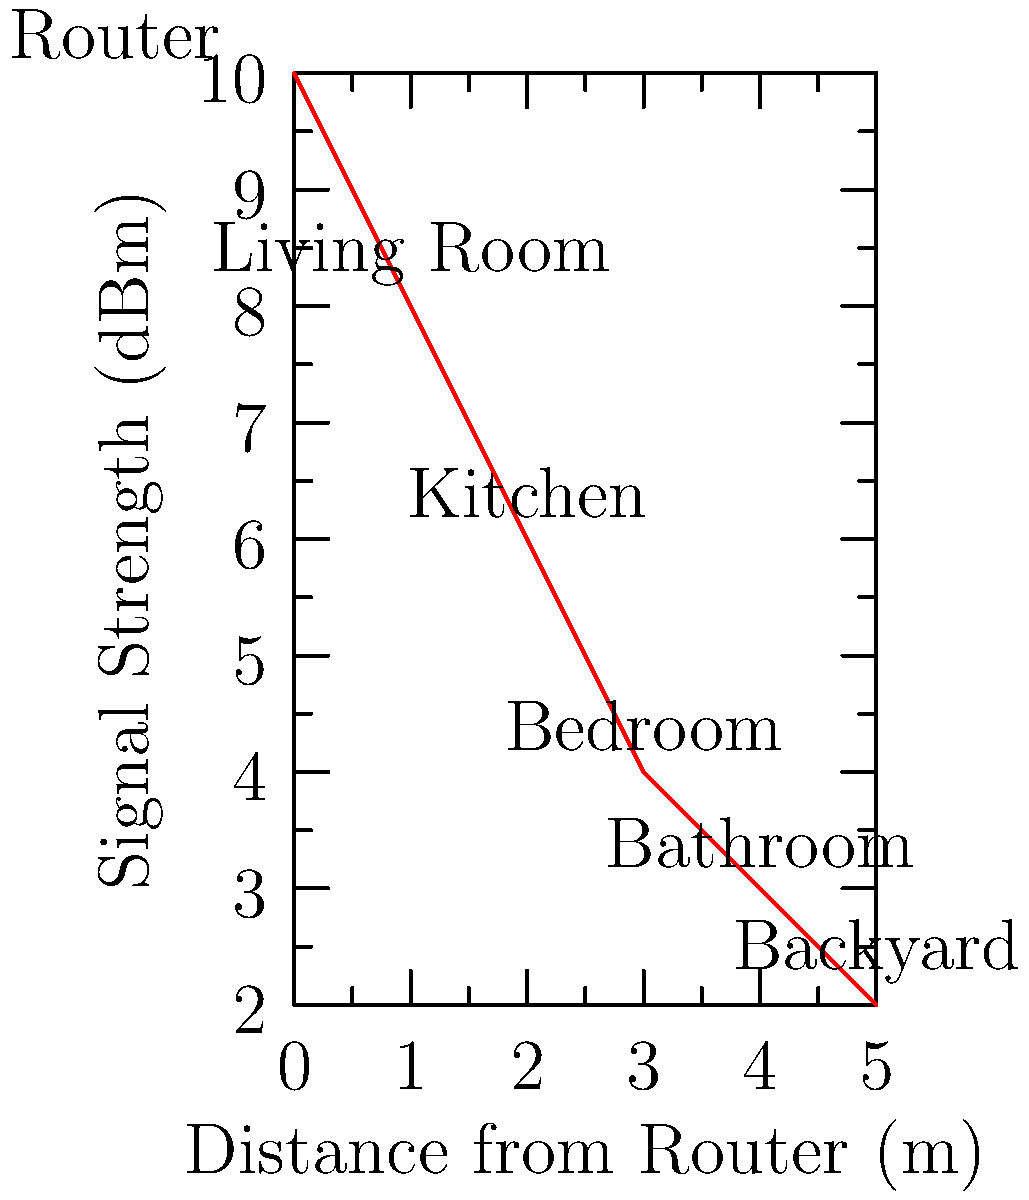You're helping your friend set up Wi-Fi in their new apartment for an upcoming gaming tournament. Given the signal strength distribution shown in the graph, which area would be the best location for the gaming setup to ensure a strong and stable connection? To determine the best location for the gaming setup, we need to analyze the Wi-Fi signal strength across different areas of the apartment:

1. The graph shows the relationship between distance from the router and signal strength in dBm (decibels-milliwatts).
2. A higher dBm value indicates a stronger signal.
3. The areas shown on the graph are:
   - Router location: 0m, 10 dBm
   - Living Room: 1m, 8 dBm
   - Kitchen: 2m, 6 dBm
   - Bedroom: 3m, 4 dBm
   - Bathroom: 4m, 3 dBm
   - Backyard: 5m, 2 dBm

4. For a gaming setup, we want the strongest and most stable connection possible.
5. The strongest signal is closest to the router, with signal strength decreasing as distance increases.
6. The Living Room has the highest signal strength (8 dBm) among the named areas, and it's closest to the router.

Therefore, the Living Room would be the best location for the gaming setup to ensure a strong and stable connection for the upcoming tournament.
Answer: Living Room 